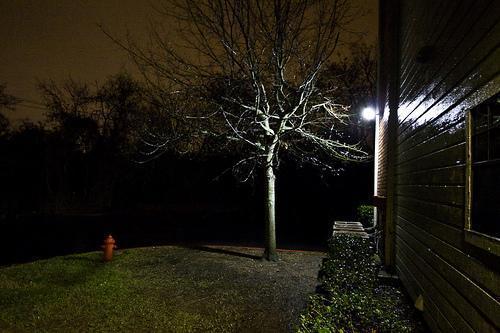How many windows are there?
Give a very brief answer. 1. How many people in the audience are wearing a yellow jacket?
Give a very brief answer. 0. 